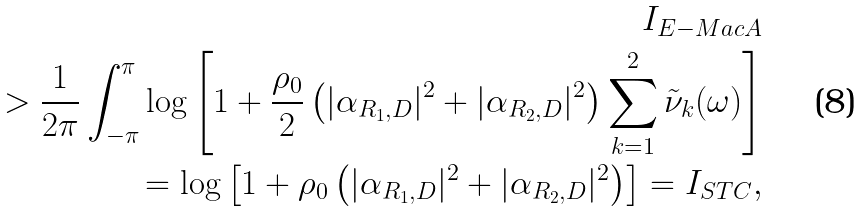<formula> <loc_0><loc_0><loc_500><loc_500>I _ { E - M a c A } \\ > \frac { 1 } { 2 \pi } \int _ { - \pi } ^ { \pi } \log \left [ 1 + \frac { \rho _ { 0 } } { 2 } \left ( | \alpha _ { R _ { 1 } , D } | ^ { 2 } + | \alpha _ { R _ { 2 } , D } | ^ { 2 } \right ) \sum _ { k = 1 } ^ { 2 } \tilde { \nu } _ { k } ( \omega ) \right ] \\ = \log \left [ 1 + \rho _ { 0 } \left ( | \alpha _ { R _ { 1 } , D } | ^ { 2 } + | \alpha _ { R _ { 2 } , D } | ^ { 2 } \right ) \right ] = I _ { S T C } ,</formula> 